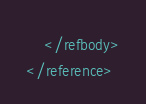Convert code to text. <code><loc_0><loc_0><loc_500><loc_500><_XML_>    </refbody>
</reference>
</code> 